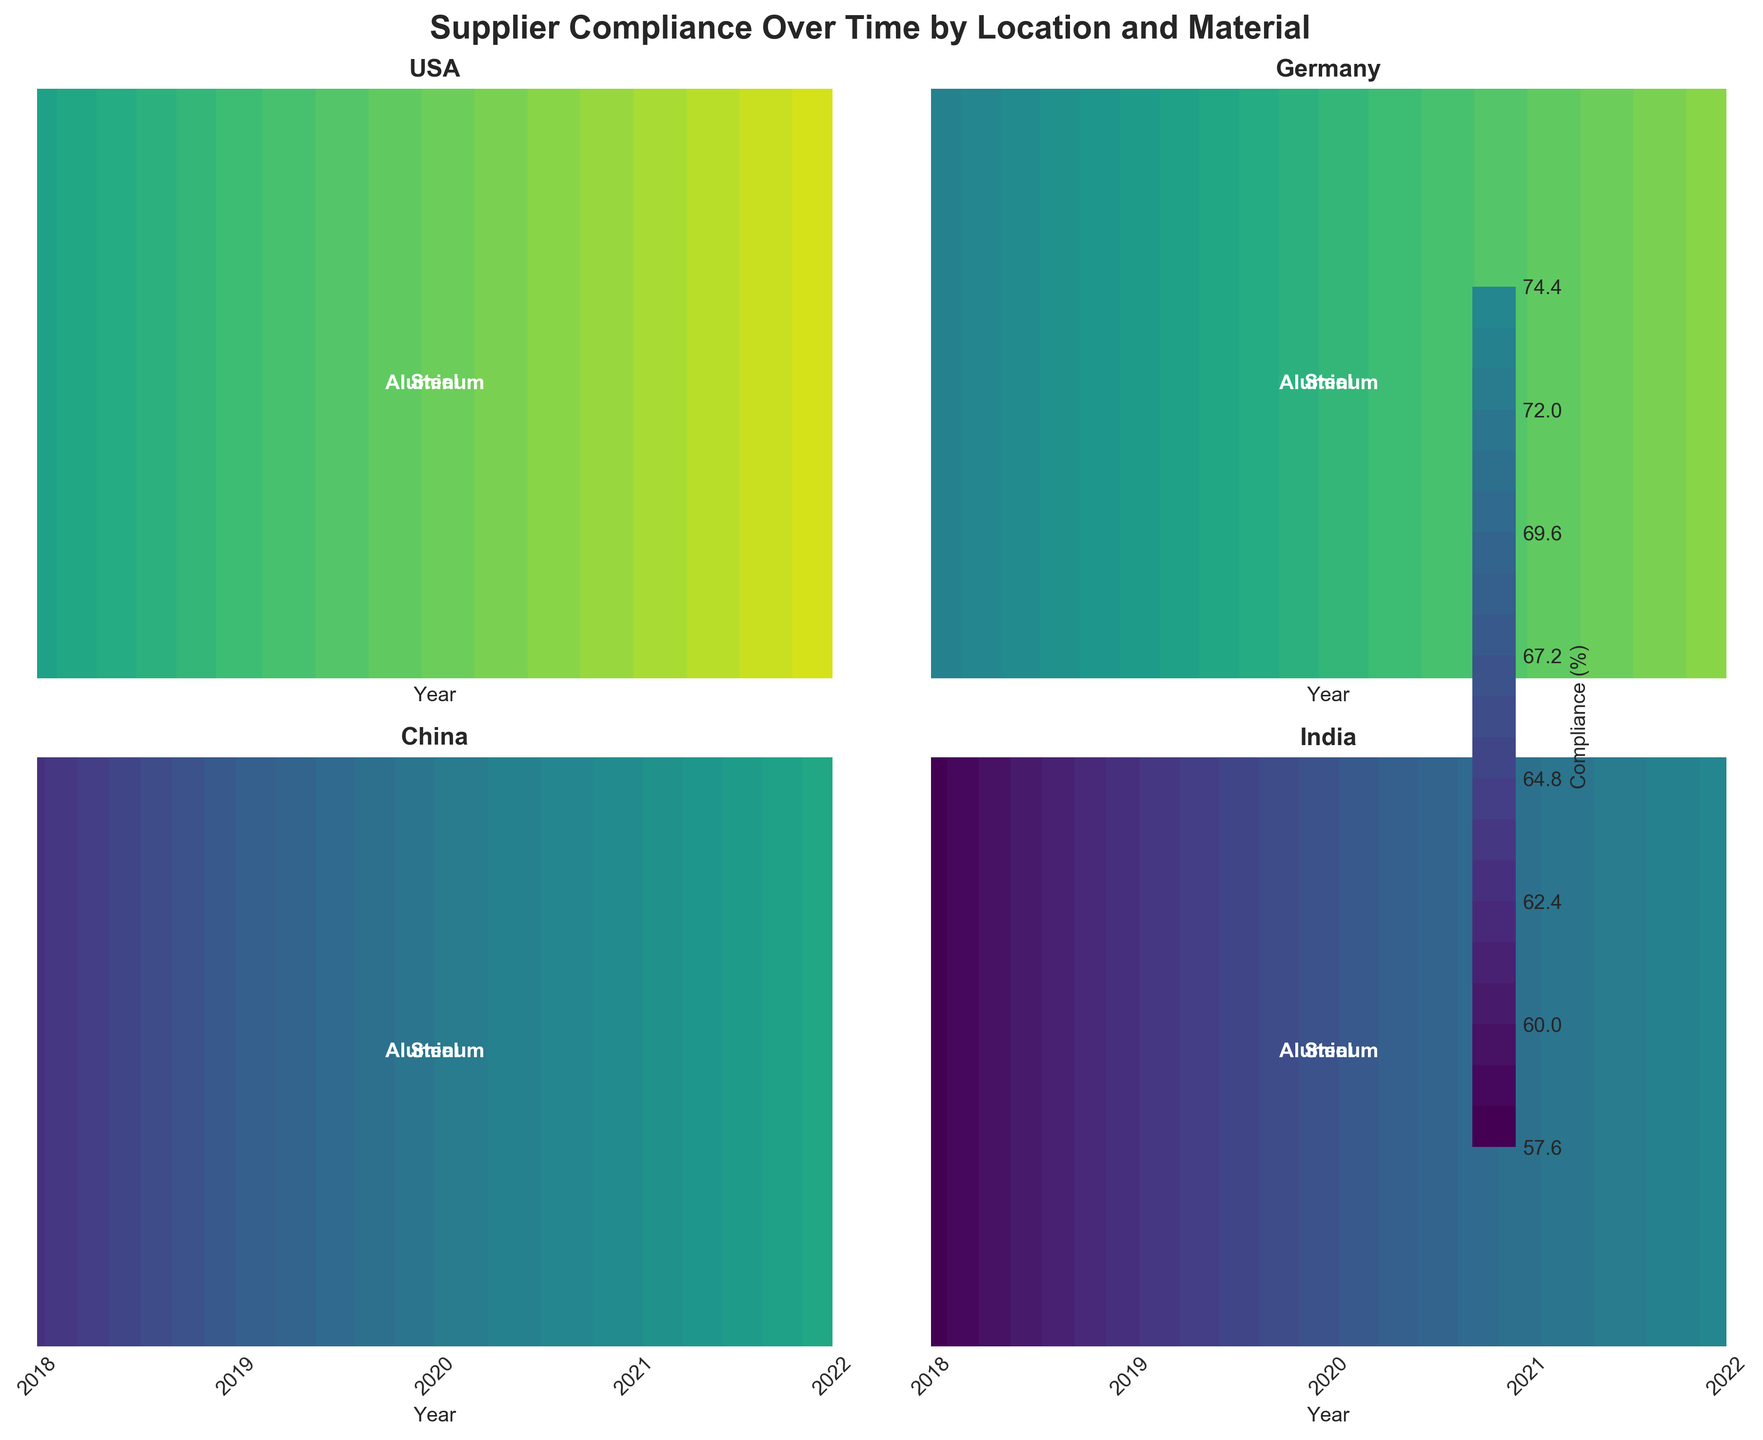How many years are displayed on the x-axis? The x-axis of each subplot is labeled with the years. By counting the years from 2018 to 2022, there are 5 distinct years displayed.
Answer: 5 Which location has the highest compliance for steel in 2022? The subplot for each location shows different compliance levels for materials over time. By looking at the contour for steel in each location's subplot at the year 2022, the USA has the highest compliance level.
Answer: USA Which material shows the steadiest increase in compliance in Germany? Observing the contour plots for steel and aluminum in Germany’s subplot, both materials increase steadily. However, steel shows more consistent yearly increments.
Answer: Steel What is the compliance trend for aluminum in China? Refer to the aluminum contour for China. It displays increasing compliance from 2018 to 2022, showing a positive trend.
Answer: Increasing Compare the compliance of steel in USA and India in 2021. Which is higher? Looking at the 2021 compliance levels for steel in both the USA and India subplots, the contour for the USA shows higher compliance than India.
Answer: USA Which year shows the highest compliance for aluminum in India? By examining the contour for aluminum in the India subplot, 2022 is the year with the highest compliance.
Answer: 2022 What’s the average compliance level for steel across all locations in 2020? Analyzing the 2020 compliance levels for steel in each subplot: USA (88), Germany (83), China (75), and India (70). The average of these values is (88+83+75+70)/4 = 79.
Answer: 79 In which location does aluminum show a larger compliance increase from 2018 to 2022: China or Germany? Evaluating the compliance increase for aluminum from 2018 to 2022 in both China and Germany: China (63 to 79) has an increase of 16, while Germany (73 to 87) has an increase of 14. Therefore, China shows a larger increase.
Answer: China Which two materials have more comparable compliance levels in 2021 in the USA? In the USA subplot for 2021, both steel (90) and aluminum (88) have close compliance levels.
Answer: Steel and Aluminum Which location depicts the lowest overall compliance levels across both materials displayed? Assessing all subplots, India shows the lowest overall compliance levels across both steel and aluminum when compared to other locations.
Answer: India 